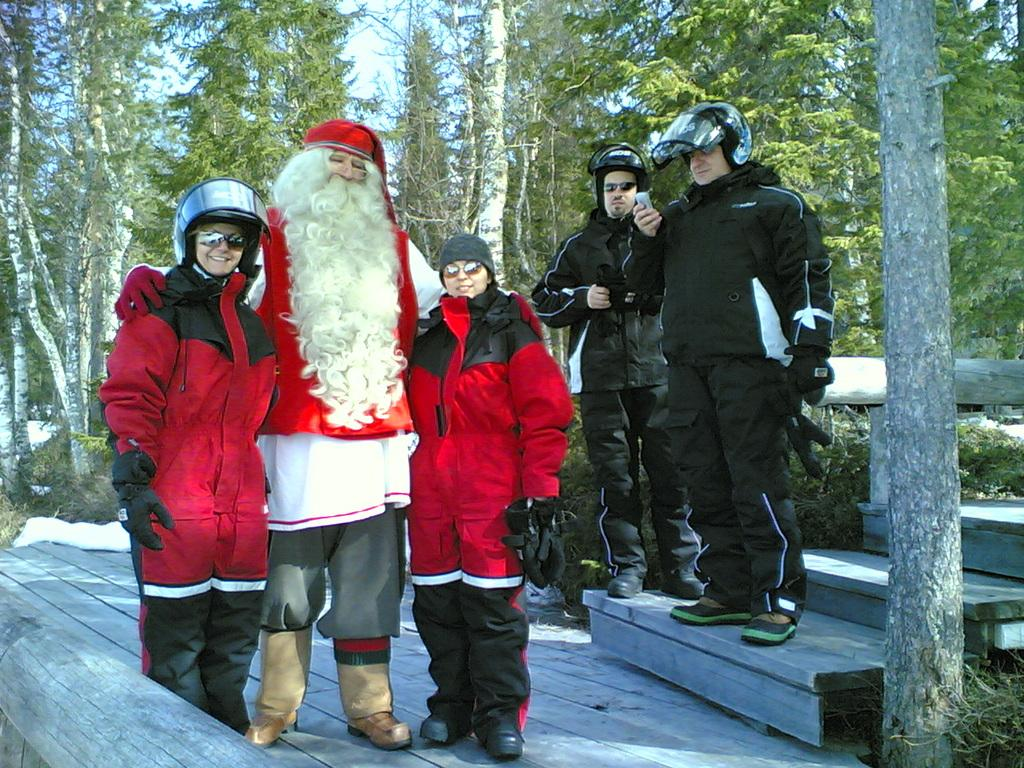How many people are in the image? There is a group of people in the image. Can you describe the attire of one of the individuals? There is a man in fancy dress in the image. What can be seen in the background of the image? There are trees and the sky visible in the background of the image. What type of ornament is hanging from the tree in the image? There is no ornament hanging from the tree in the image; only trees and the sky are visible in the background. What type of food is being served at the event in the image? There is no indication of food or an event in the image; it only shows a group of people, a man in fancy dress, trees, and the sky. 